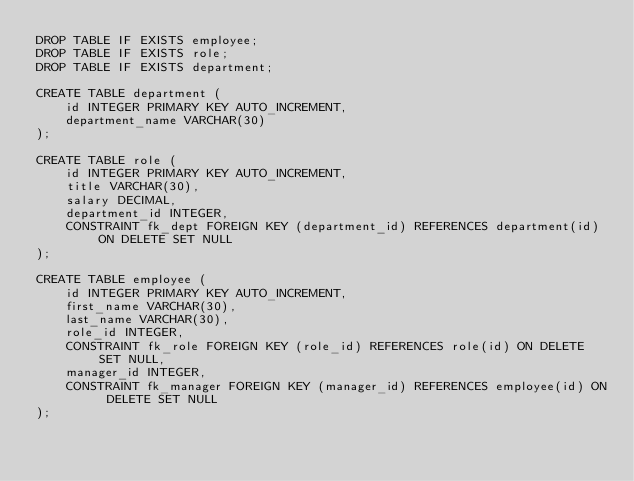<code> <loc_0><loc_0><loc_500><loc_500><_SQL_>DROP TABLE IF EXISTS employee;
DROP TABLE IF EXISTS role;
DROP TABLE IF EXISTS department;

CREATE TABLE department (
    id INTEGER PRIMARY KEY AUTO_INCREMENT,
    department_name VARCHAR(30)
);

CREATE TABLE role (
    id INTEGER PRIMARY KEY AUTO_INCREMENT,
    title VARCHAR(30),
    salary DECIMAL,
    department_id INTEGER,
    CONSTRAINT fk_dept FOREIGN KEY (department_id) REFERENCES department(id) ON DELETE SET NULL
);

CREATE TABLE employee (
    id INTEGER PRIMARY KEY AUTO_INCREMENT,
    first_name VARCHAR(30),
    last_name VARCHAR(30),
    role_id INTEGER,
    CONSTRAINT fk_role FOREIGN KEY (role_id) REFERENCES role(id) ON DELETE SET NULL,
    manager_id INTEGER,
    CONSTRAINT fk_manager FOREIGN KEY (manager_id) REFERENCES employee(id) ON DELETE SET NULL
);
</code> 